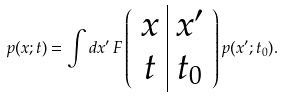<formula> <loc_0><loc_0><loc_500><loc_500>p ( x ; t ) = \int d x ^ { \prime } \, F \left ( \begin{array} { c | c } x & x ^ { \prime } \\ t & t _ { 0 } \end{array} \right ) p ( x ^ { \prime } ; t _ { 0 } ) .</formula> 